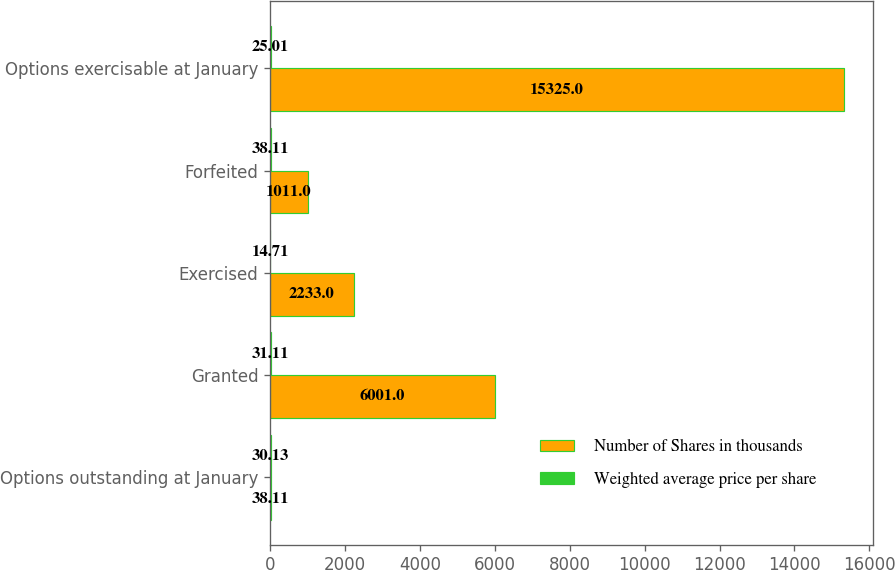Convert chart. <chart><loc_0><loc_0><loc_500><loc_500><stacked_bar_chart><ecel><fcel>Options outstanding at January<fcel>Granted<fcel>Exercised<fcel>Forfeited<fcel>Options exercisable at January<nl><fcel>Number of Shares in thousands<fcel>38.11<fcel>6001<fcel>2233<fcel>1011<fcel>15325<nl><fcel>Weighted average price per share<fcel>30.13<fcel>31.11<fcel>14.71<fcel>38.11<fcel>25.01<nl></chart> 